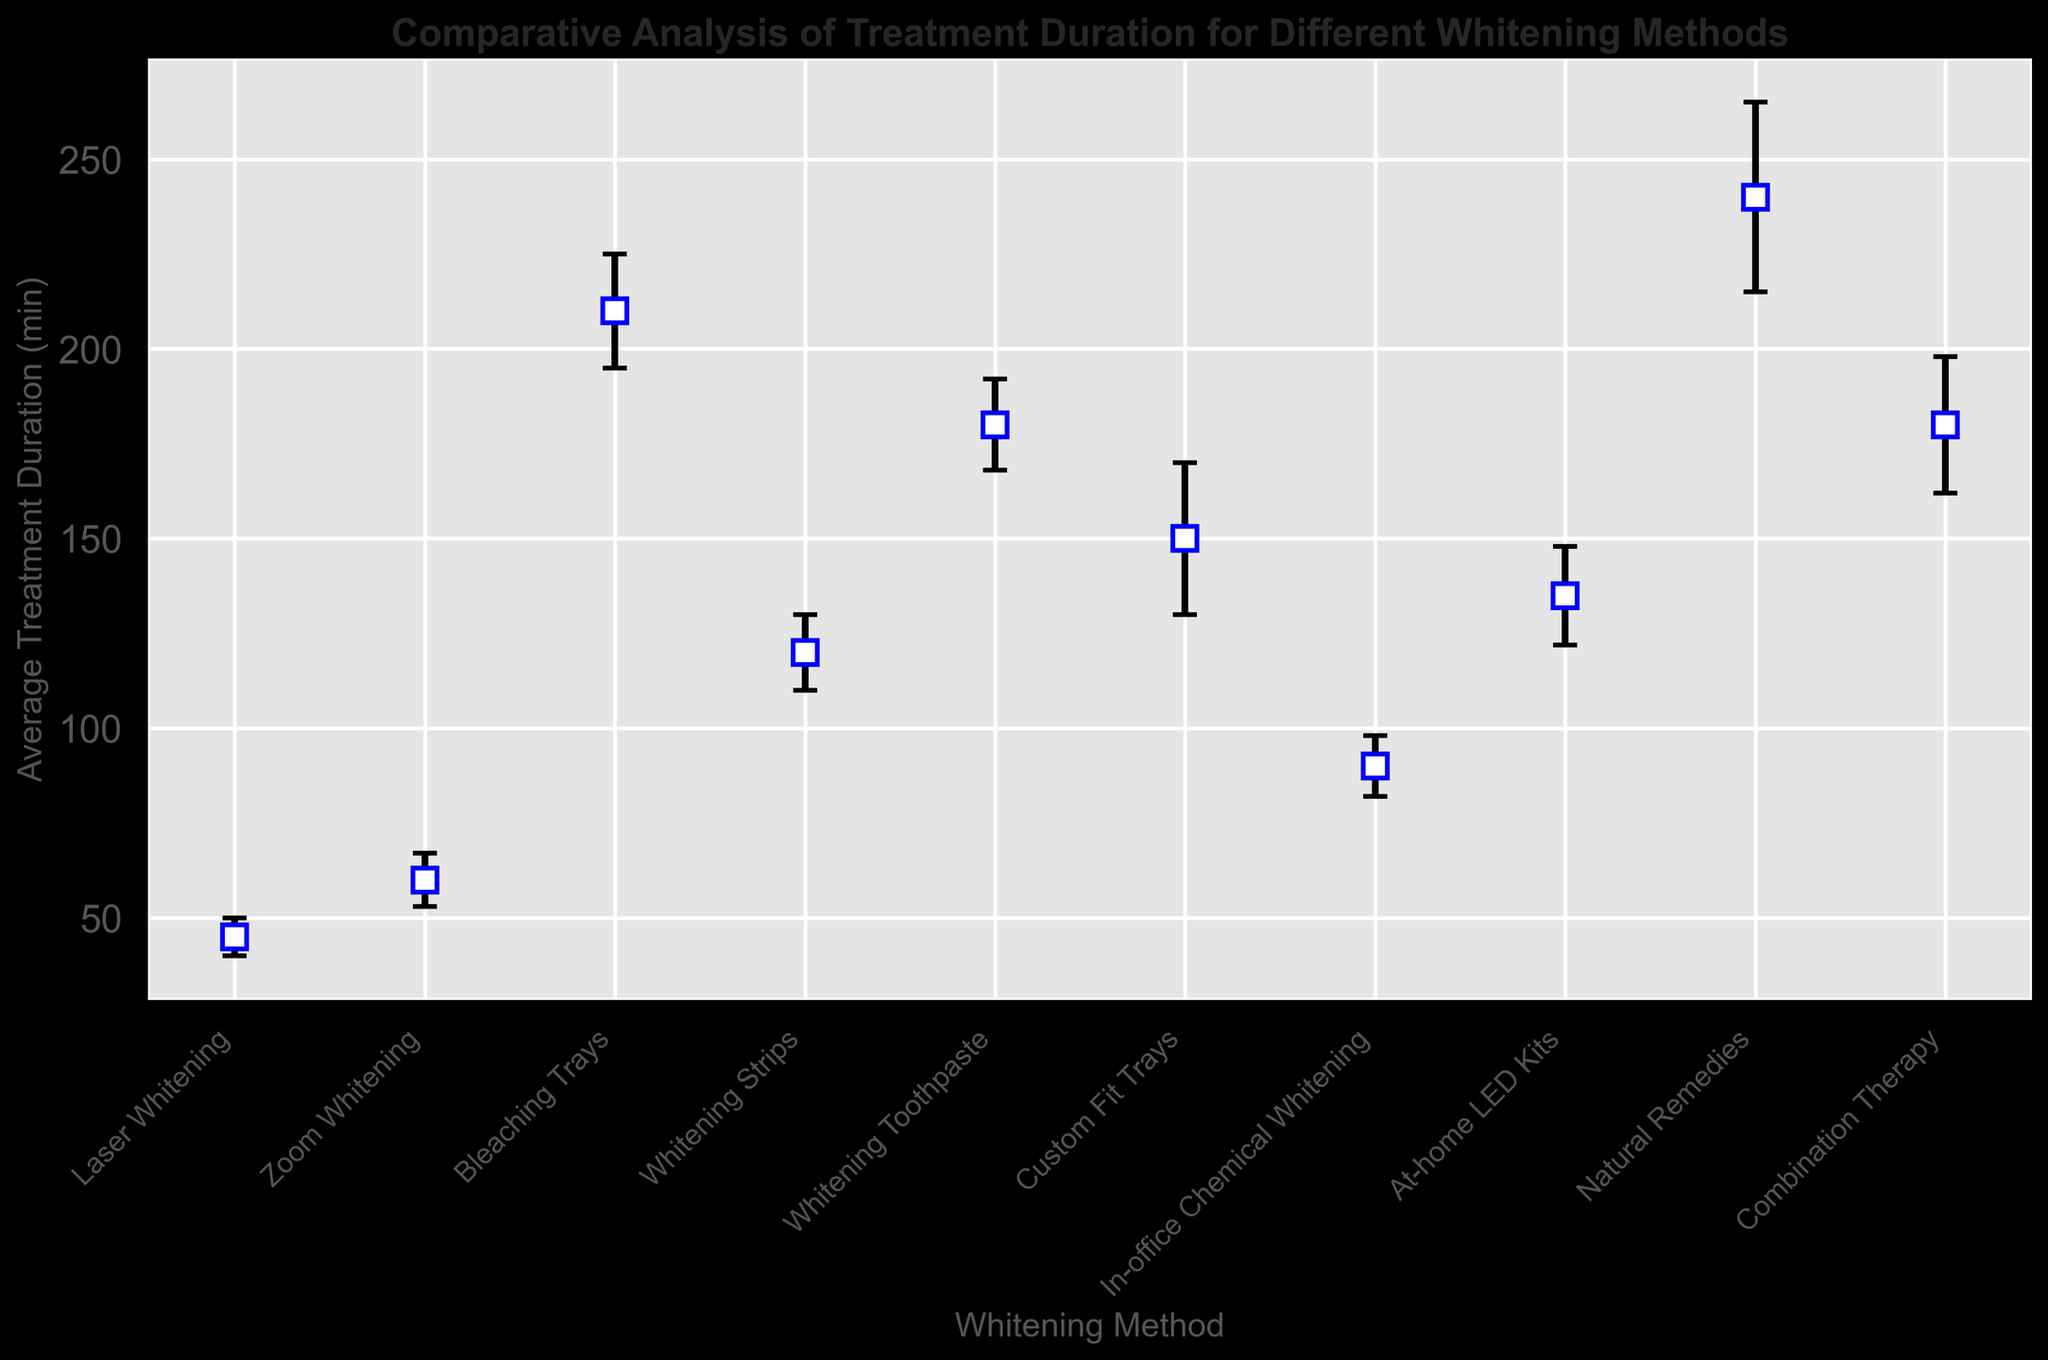What is the average treatment duration for Zoom Whitening compared to Laser Whitening? To answer this, look at the average treatment duration values for both Zoom Whitening and Laser Whitening. Zoom Whitening has an average duration of 60 minutes, and Laser Whitening has an average duration of 45 minutes. Thus, Zoom Whitening takes 15 minutes longer.
Answer: Zoom Whitening is 15 minutes longer than Laser Whitening Which whitening method has the highest variability in treatment duration? To determine the whitening method with the highest variability, look at the Standard Deviation column. Natural Remedies has the highest standard deviation of 25 minutes, indicating the greatest variability.
Answer: Natural Remedies How much longer does the treatment for Bleaching Trays take on average compared to In-office Chemical Whitening? Find the difference in average treatment durations. Bleaching Trays take 210 minutes, and In-office Chemical Whitening takes 90 minutes. So, the difference is 210 - 90 = 120 minutes.
Answer: 120 minutes Which treatments have a shorter average duration than Custom Fit Trays? Custom Fit Trays have an average duration of 150 minutes. Compare this to other treatments. Laser Whitening (45 min), Zoom Whitening (60 min), In-office Chemical Whitening (90 min), Whitening Strips (120 min), and At-home LED Kits (135 min) all are shorter.
Answer: Laser Whitening, Zoom Whitening, In-office Chemical Whitening, Whitening Strips, and At-home LED Kits What is the average treatment duration for the method with the least variability? Look for the whitening method with the smallest standard deviation. Laser Whitening has the smallest standard deviation of 5 minutes. The average treatment duration for Laser Whitening is 45 minutes.
Answer: 45 minutes Rank the average treatment durations from lowest to highest. List all average treatment durations and sort them. The values are 45, 60, 90, 120, 135, 150, 180, 180, 210, 240. The ranking from lowest to highest: Laser Whitening, Zoom Whitening, In-office Chemical Whitening, Whitening Strips, At-home LED Kits, Custom Fit Trays, Whitening Toothpaste & Combination Therapy, Bleaching Trays, Natural Remedies.
Answer: Laser Whitening, Zoom Whitening, In-office Chemical Whitening, Whitening Strips, At-home LED Kits, Custom Fit Trays, Whitening Toothpaste and Combination Therapy, Bleaching Trays, Natural Remedies Which method has the highest average treatment duration? Look at the Average Treatment Duration column to find the highest value. Natural Remedies have the highest average treatment duration at 240 minutes.
Answer: Natural Remedies How much longer, on average, is the duration for Whitening Toothpaste compared to Whitening Strips? Identify the average durations for each method. Whitening Toothpaste takes 180 minutes, and Whitening Strips take 120 minutes. The difference is 180 - 120 = 60 minutes.
Answer: 60 minutes How many methods have an average treatment duration greater than 100 minutes? Compare each average treatment duration to 100 minutes. Whitening Strips (120 min), Whitening Toothpaste (180 min), Custom Fit Trays (150 min), At-home LED Kits (135 min), Combination Therapy (180 min), Bleaching Trays (210 min), Natural Remedies (240 min) are all greater. That's 7 methods.
Answer: 7 methods What is the range of the average treatment durations for the methods? To find the range, subtract the smallest average treatment duration from the largest. The smallest is Laser Whitening at 45 minutes, and the largest is Natural Remedies at 240 minutes. The range is 240 - 45 = 195 minutes.
Answer: 195 minutes 